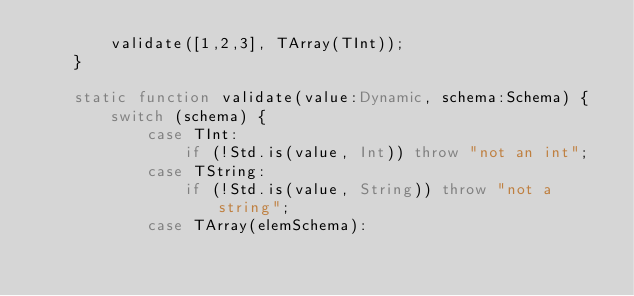Convert code to text. <code><loc_0><loc_0><loc_500><loc_500><_Haxe_>        validate([1,2,3], TArray(TInt));
    }

    static function validate(value:Dynamic, schema:Schema) {
        switch (schema) {
            case TInt:
                if (!Std.is(value, Int)) throw "not an int";
            case TString:
                if (!Std.is(value, String)) throw "not a string";
            case TArray(elemSchema):</code> 